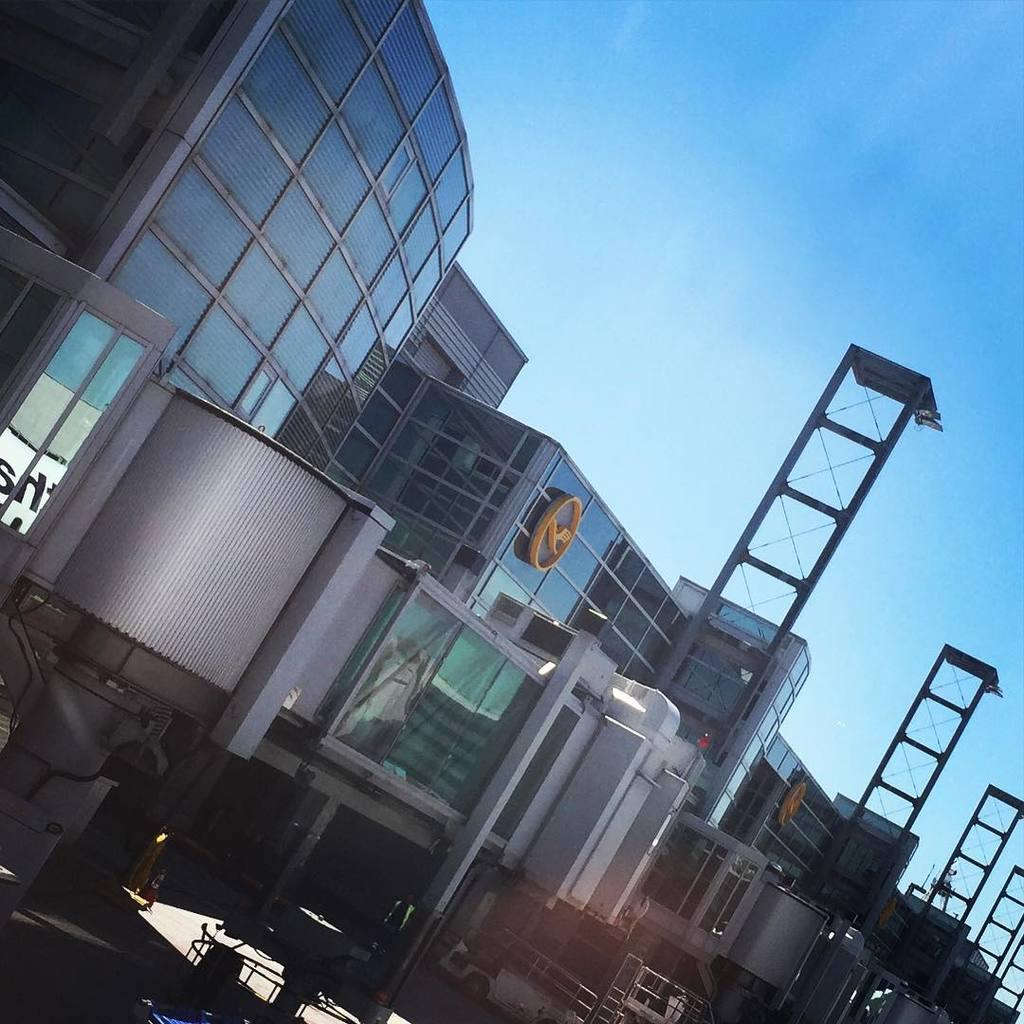What is located in the center of the image? There are buildings in the center of the image. What can be seen in the background of the image? The sky is visible in the background of the image. What type of organization is depicted in the image? There is no organization depicted in the image; it features buildings and the sky. What appliance can be seen in the image? There are no appliances present in the image. 